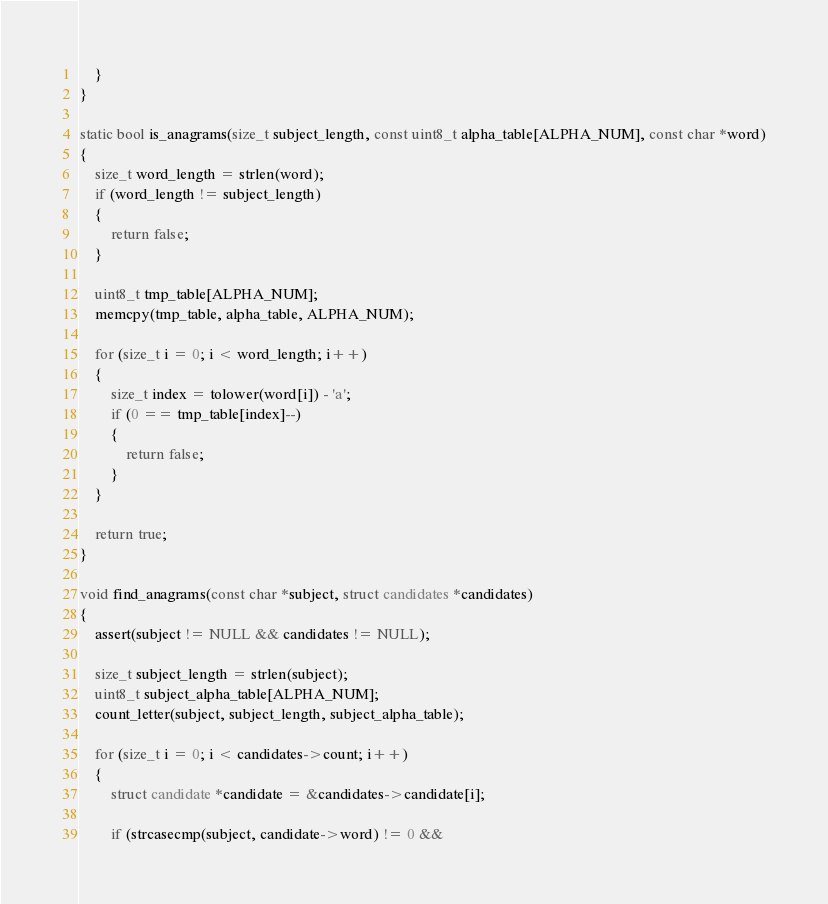Convert code to text. <code><loc_0><loc_0><loc_500><loc_500><_C_>    }
}

static bool is_anagrams(size_t subject_length, const uint8_t alpha_table[ALPHA_NUM], const char *word)
{
    size_t word_length = strlen(word);
    if (word_length != subject_length)
    {
        return false;
    }

    uint8_t tmp_table[ALPHA_NUM];
    memcpy(tmp_table, alpha_table, ALPHA_NUM);

    for (size_t i = 0; i < word_length; i++)
    {
        size_t index = tolower(word[i]) - 'a';
        if (0 == tmp_table[index]--)
        {
            return false;
        }
    }

    return true;
}

void find_anagrams(const char *subject, struct candidates *candidates)
{
    assert(subject != NULL && candidates != NULL);

    size_t subject_length = strlen(subject);
    uint8_t subject_alpha_table[ALPHA_NUM];
    count_letter(subject, subject_length, subject_alpha_table);

    for (size_t i = 0; i < candidates->count; i++)
    {
        struct candidate *candidate = &candidates->candidate[i];

        if (strcasecmp(subject, candidate->word) != 0 &&</code> 